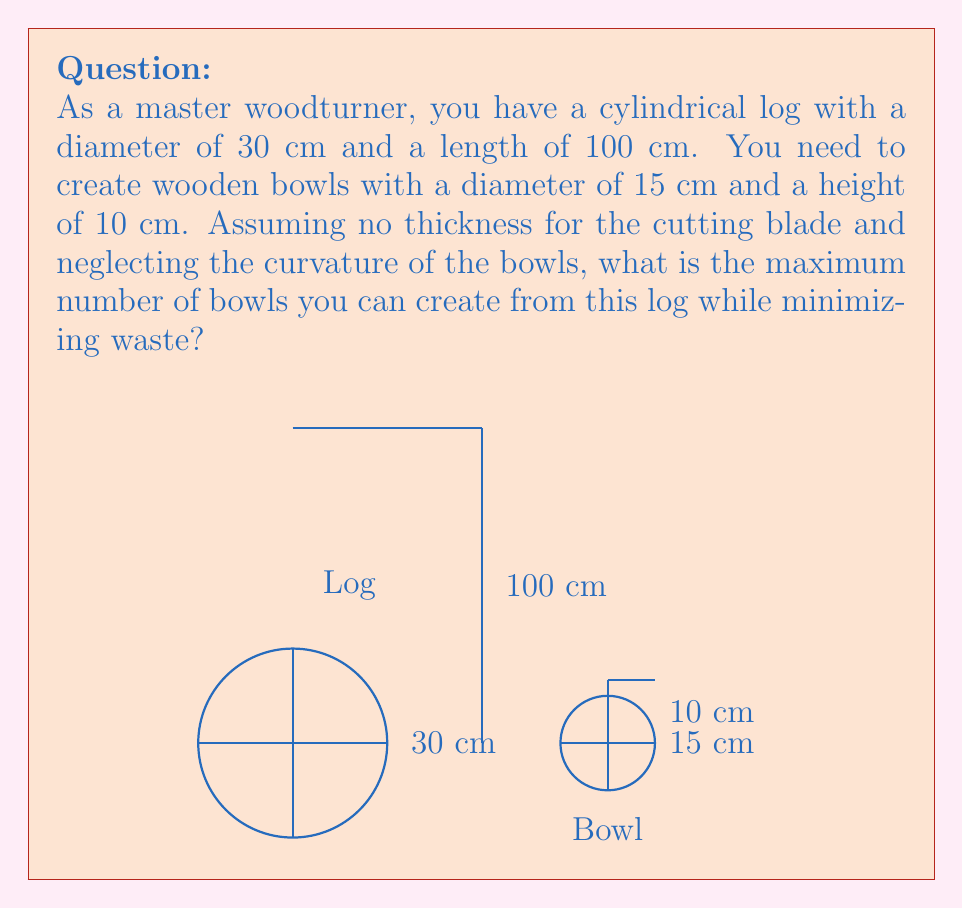Could you help me with this problem? Let's approach this step-by-step:

1) First, we need to determine how many bowls can fit across the diameter of the log:
   $$\text{Number across} = \lfloor\frac{\text{Log diameter}}{\text{Bowl diameter}}\rfloor = \lfloor\frac{30}{15}\rfloor = 2$$

2) Next, we calculate how many layers of bowls can fit along the length of the log:
   $$\text{Number of layers} = \lfloor\frac{\text{Log length}}{\text{Bowl height}}\rfloor = \lfloor\frac{100}{10}\rfloor = 10$$

3) Now, we need to determine the most efficient arrangement. We have two options:
   a) Arrange the bowls in a square pattern (2x2)
   b) Arrange the bowls in a hexagonal pattern

4) For the square pattern:
   $$\text{Bowls per layer} = 2 \times 2 = 4$$
   $$\text{Total bowls} = 4 \times 10 = 40$$

5) For the hexagonal pattern:
   In a hexagonal arrangement, we can fit 7 bowls per two layers:
   $$\text{Bowls per two layers} = 7$$
   $$\text{Number of double layers} = \lfloor\frac{10}{2}\rfloor = 5$$
   $$\text{Total bowls} = 7 \times 5 = 35$$

6) The square pattern yields more bowls, so it's the most efficient cutting pattern.

Therefore, the maximum number of bowls that can be created while minimizing waste is 40.
Answer: 40 bowls 